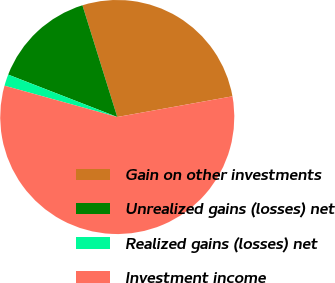<chart> <loc_0><loc_0><loc_500><loc_500><pie_chart><fcel>Gain on other investments<fcel>Unrealized gains (losses) net<fcel>Realized gains (losses) net<fcel>Investment income<nl><fcel>26.98%<fcel>14.29%<fcel>1.59%<fcel>57.14%<nl></chart> 